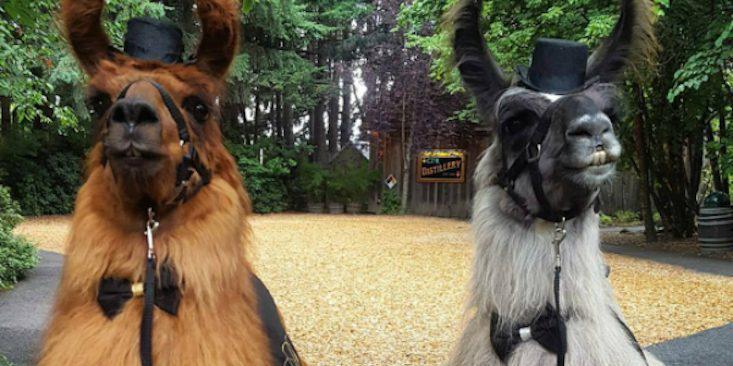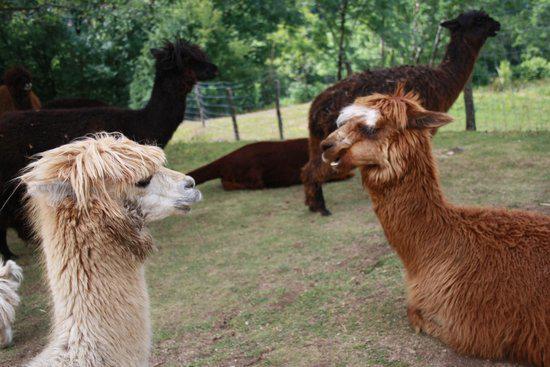The first image is the image on the left, the second image is the image on the right. For the images displayed, is the sentence "Two llamas are wearing bow ties and little hats." factually correct? Answer yes or no. Yes. 